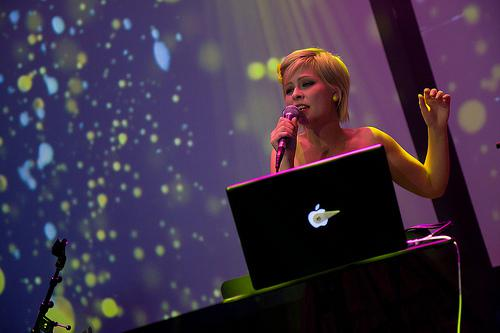Question: what is she doing?
Choices:
A. Singing.
B. Shouting.
C. Speaking.
D. Dancing.
Answer with the letter. Answer: A Question: who is in the photo?
Choices:
A. A man.
B. A woman.
C. A couple.
D. Two kids.
Answer with the letter. Answer: B Question: what logo is on the laptop?
Choices:
A. Apple.
B. Dell.
C. Gateway.
D. Emachine.
Answer with the letter. Answer: A Question: what is in front of the woman?
Choices:
A. A window.
B. A man.
C. A laptop.
D. A store.
Answer with the letter. Answer: C Question: where was the photo taken?
Choices:
A. Restroom.
B. Mobile home.
C. At the concert.
D. Pantry.
Answer with the letter. Answer: C 